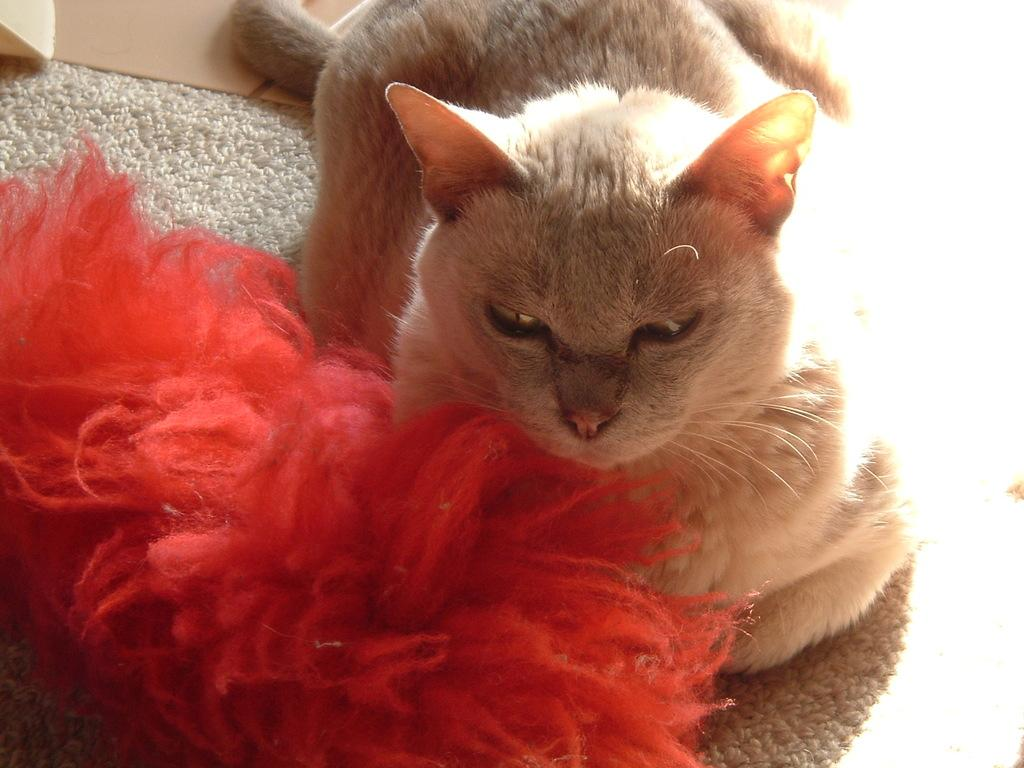What is the main subject in the center of the image? There is a cat in the center of the image. What type of surface is visible in the background? There is a floor in the background. What other objects can be seen in the background? There is a mat and wool in the background. What date is marked on the calendar in the image? There is no calendar present in the image. What shape is the cat in the image? The cat is not a shape; it is a living animal. 